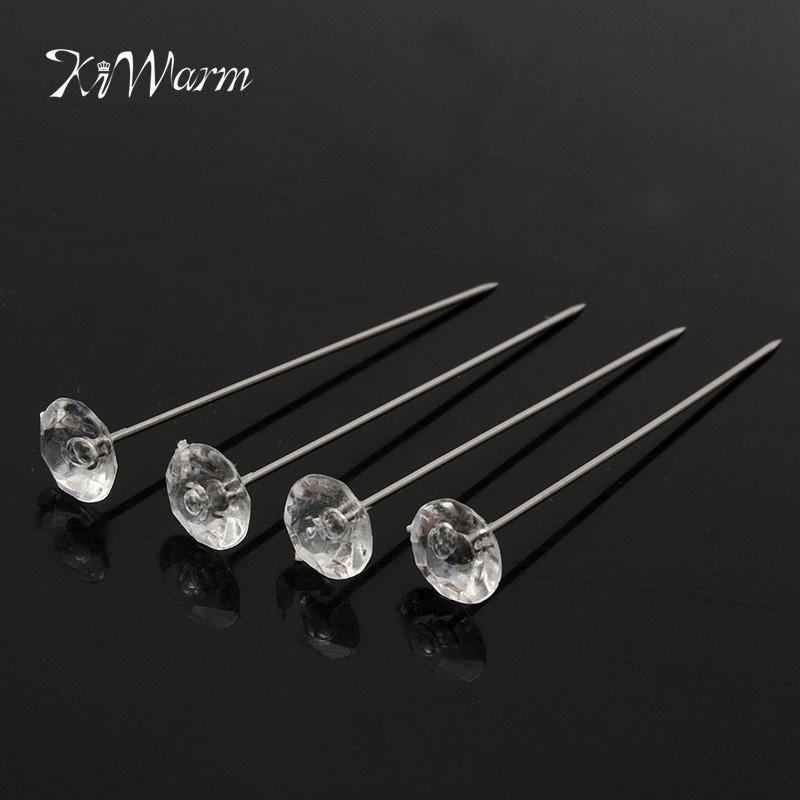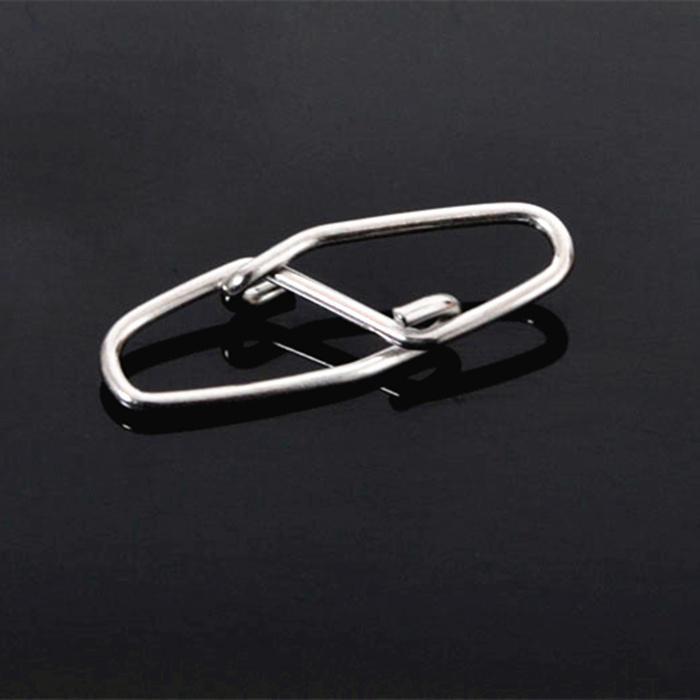The first image is the image on the left, the second image is the image on the right. Assess this claim about the two images: "There are at least four pins in the image on the right.". Correct or not? Answer yes or no. No. 